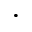Convert formula to latex. <formula><loc_0><loc_0><loc_500><loc_500>\cdot</formula> 